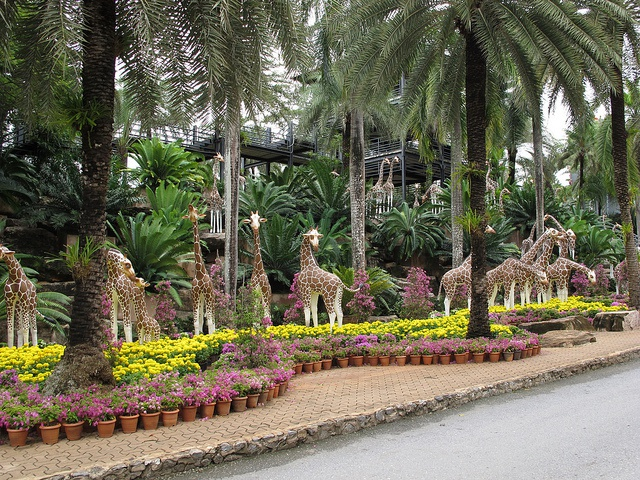Describe the objects in this image and their specific colors. I can see potted plant in black, brown, olive, and maroon tones, giraffe in black, gray, darkgray, and darkgreen tones, giraffe in black, lightgray, darkgray, gray, and maroon tones, giraffe in black, maroon, darkgray, tan, and olive tones, and giraffe in black, tan, gray, and maroon tones in this image. 